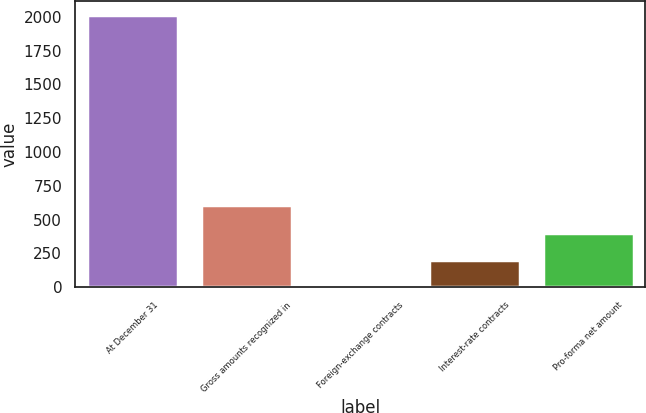<chart> <loc_0><loc_0><loc_500><loc_500><bar_chart><fcel>At December 31<fcel>Gross amounts recognized in<fcel>Foreign-exchange contracts<fcel>Interest-rate contracts<fcel>Pro-forma net amount<nl><fcel>2016<fcel>605.5<fcel>1<fcel>202.5<fcel>404<nl></chart> 